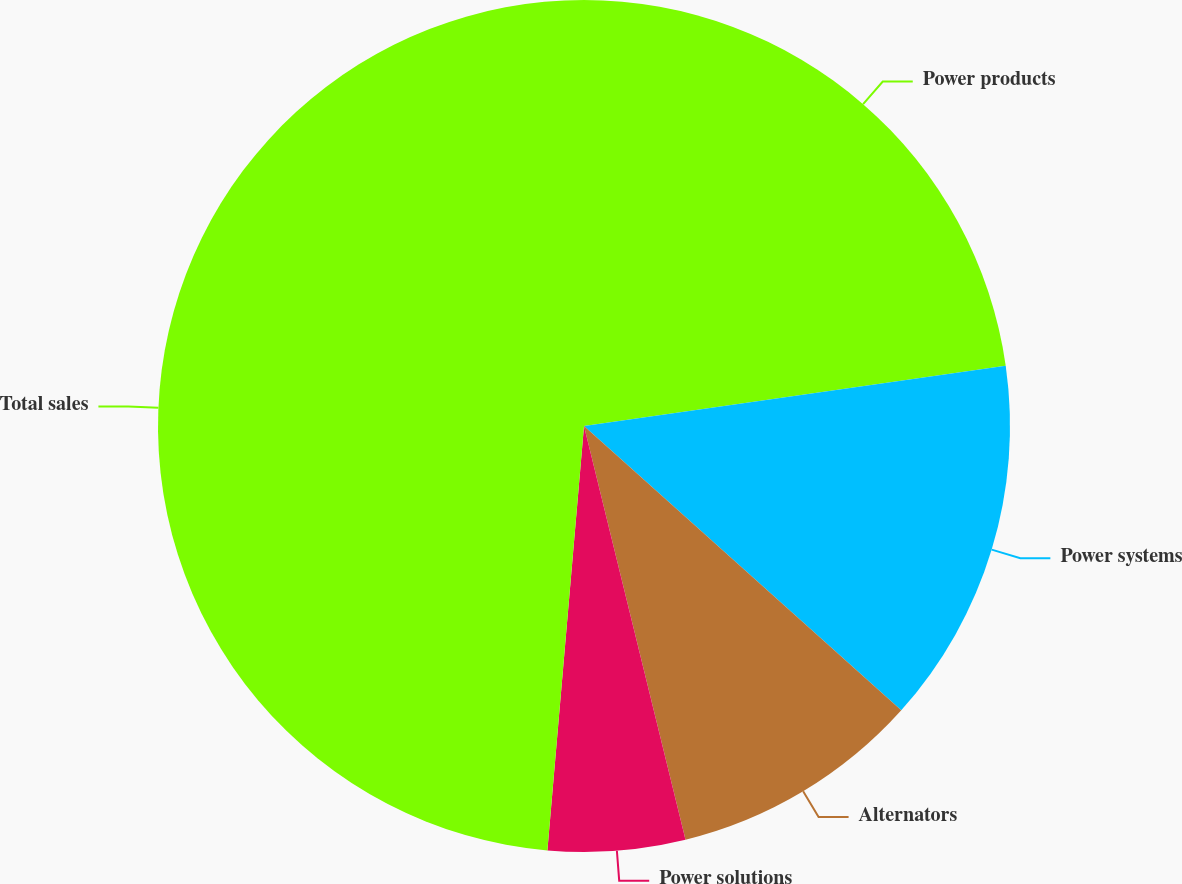Convert chart. <chart><loc_0><loc_0><loc_500><loc_500><pie_chart><fcel>Power products<fcel>Power systems<fcel>Alternators<fcel>Power solutions<fcel>Total sales<nl><fcel>22.74%<fcel>13.89%<fcel>9.54%<fcel>5.2%<fcel>48.63%<nl></chart> 